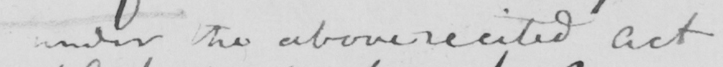What does this handwritten line say? under the above recited Act 